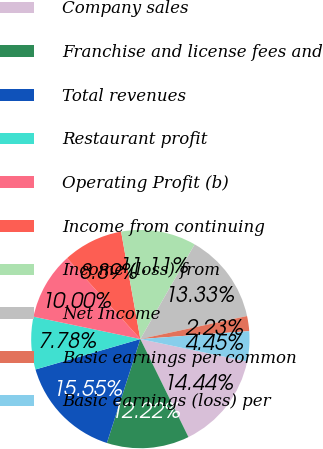<chart> <loc_0><loc_0><loc_500><loc_500><pie_chart><fcel>Company sales<fcel>Franchise and license fees and<fcel>Total revenues<fcel>Restaurant profit<fcel>Operating Profit (b)<fcel>Income from continuing<fcel>Income (loss) from<fcel>Net Income<fcel>Basic earnings per common<fcel>Basic earnings (loss) per<nl><fcel>14.44%<fcel>12.22%<fcel>15.55%<fcel>7.78%<fcel>10.0%<fcel>8.89%<fcel>11.11%<fcel>13.33%<fcel>2.23%<fcel>4.45%<nl></chart> 